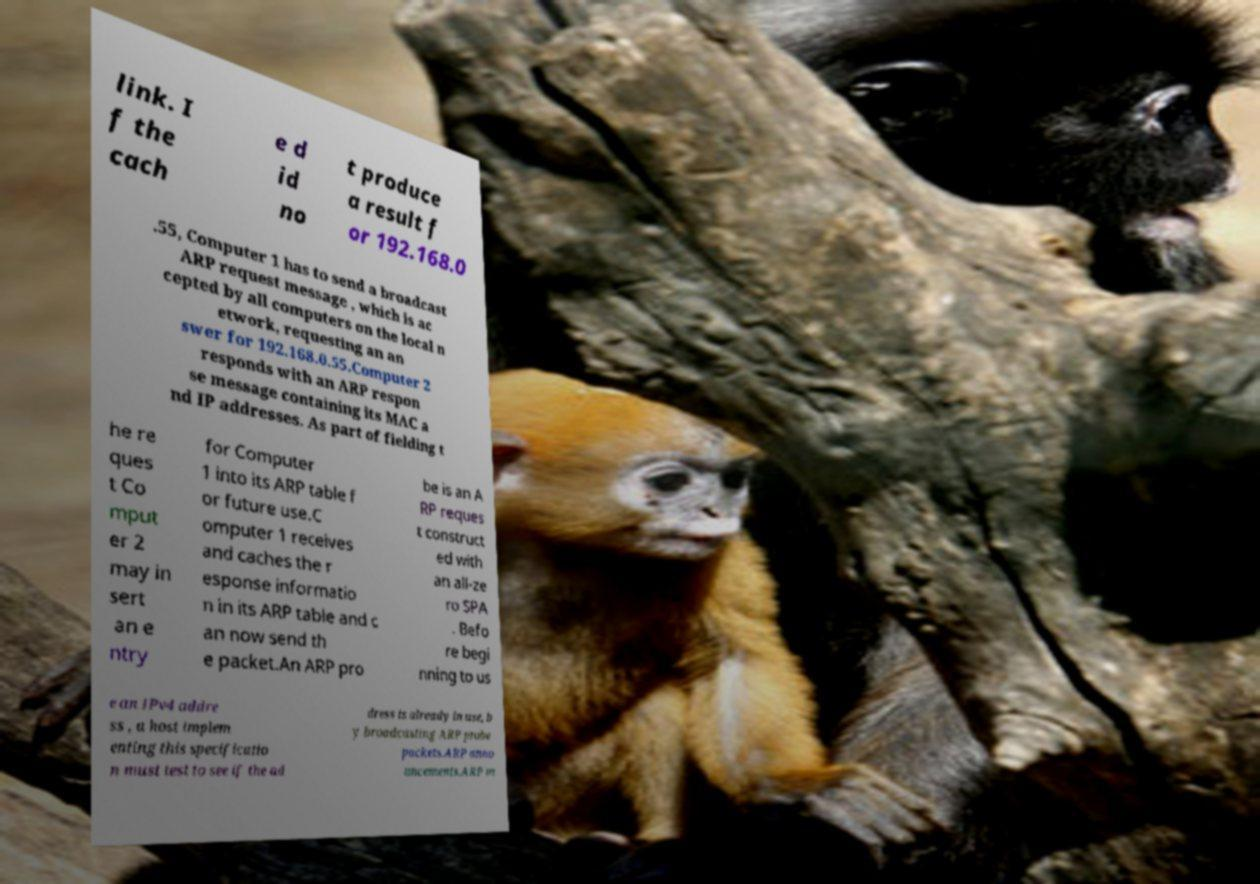For documentation purposes, I need the text within this image transcribed. Could you provide that? link. I f the cach e d id no t produce a result f or 192.168.0 .55, Computer 1 has to send a broadcast ARP request message , which is ac cepted by all computers on the local n etwork, requesting an an swer for 192.168.0.55.Computer 2 responds with an ARP respon se message containing its MAC a nd IP addresses. As part of fielding t he re ques t Co mput er 2 may in sert an e ntry for Computer 1 into its ARP table f or future use.C omputer 1 receives and caches the r esponse informatio n in its ARP table and c an now send th e packet.An ARP pro be is an A RP reques t construct ed with an all-ze ro SPA . Befo re begi nning to us e an IPv4 addre ss , a host implem enting this specificatio n must test to see if the ad dress is already in use, b y broadcasting ARP probe packets.ARP anno uncements.ARP m 